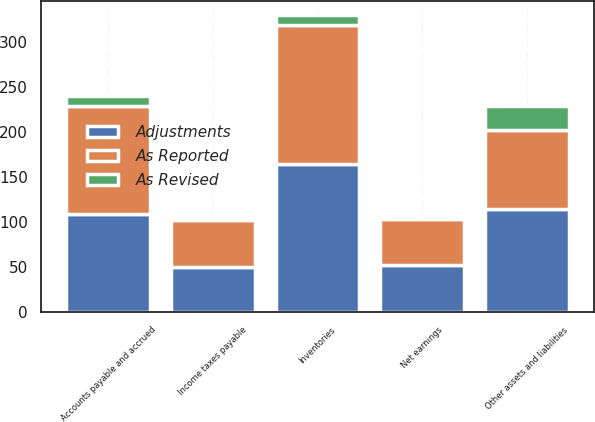<chart> <loc_0><loc_0><loc_500><loc_500><stacked_bar_chart><ecel><fcel>Net earnings<fcel>Income taxes payable<fcel>Inventories<fcel>Accounts payable and accrued<fcel>Other assets and liabilities<nl><fcel>As Reported<fcel>51.9<fcel>51.9<fcel>154.1<fcel>120.1<fcel>87.6<nl><fcel>As Revised<fcel>0.2<fcel>1.5<fcel>10.5<fcel>11.7<fcel>26.8<nl><fcel>Adjustments<fcel>51.9<fcel>50.4<fcel>164.6<fcel>108.4<fcel>114.4<nl></chart> 